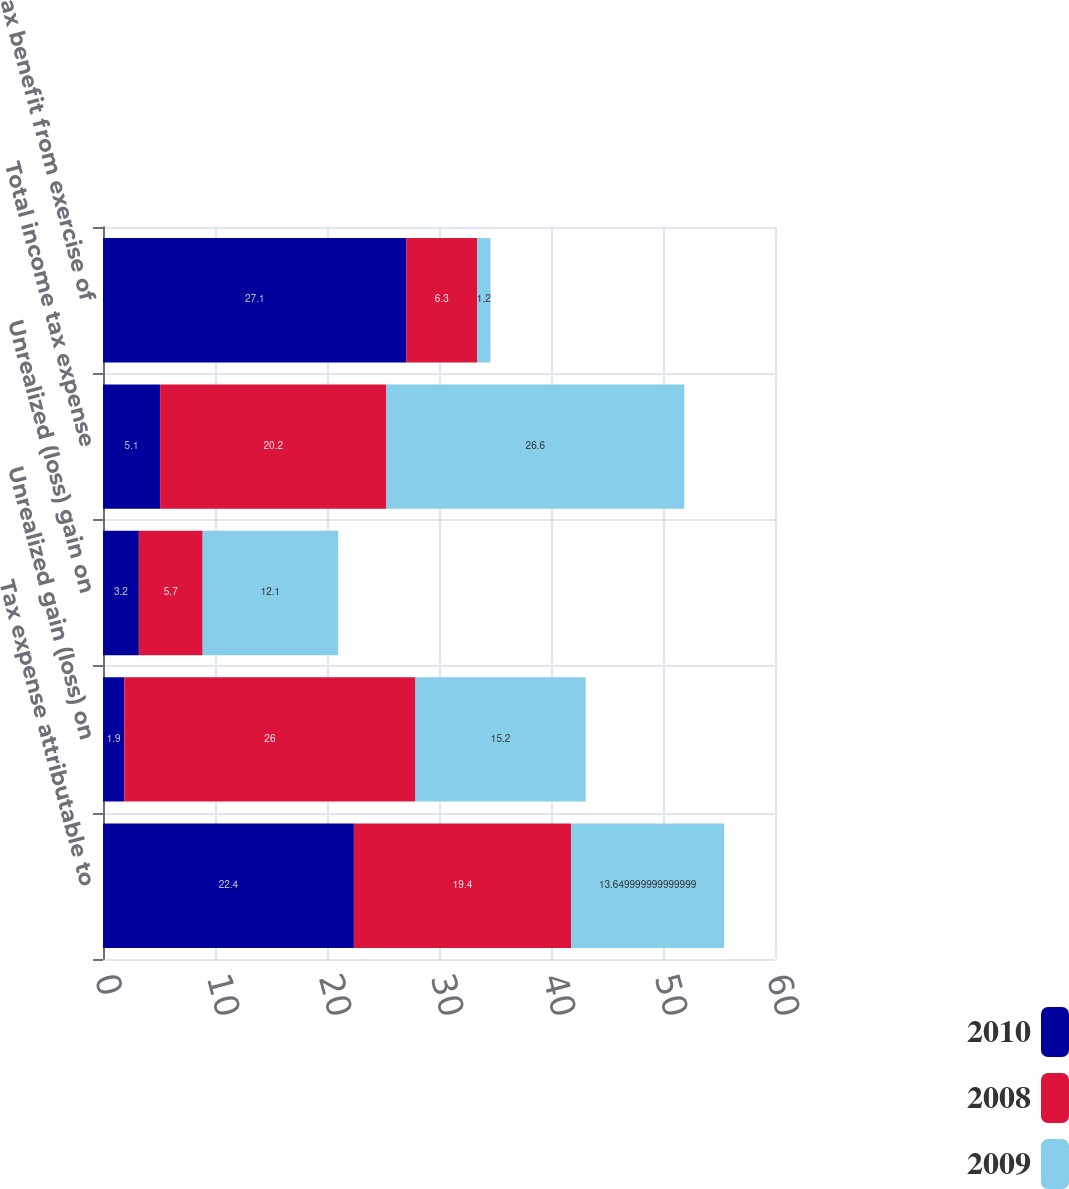Convert chart. <chart><loc_0><loc_0><loc_500><loc_500><stacked_bar_chart><ecel><fcel>Tax expense attributable to<fcel>Unrealized gain (loss) on<fcel>Unrealized (loss) gain on<fcel>Total income tax expense<fcel>Tax benefit from exercise of<nl><fcel>2010<fcel>22.4<fcel>1.9<fcel>3.2<fcel>5.1<fcel>27.1<nl><fcel>2008<fcel>19.4<fcel>26<fcel>5.7<fcel>20.2<fcel>6.3<nl><fcel>2009<fcel>13.65<fcel>15.2<fcel>12.1<fcel>26.6<fcel>1.2<nl></chart> 